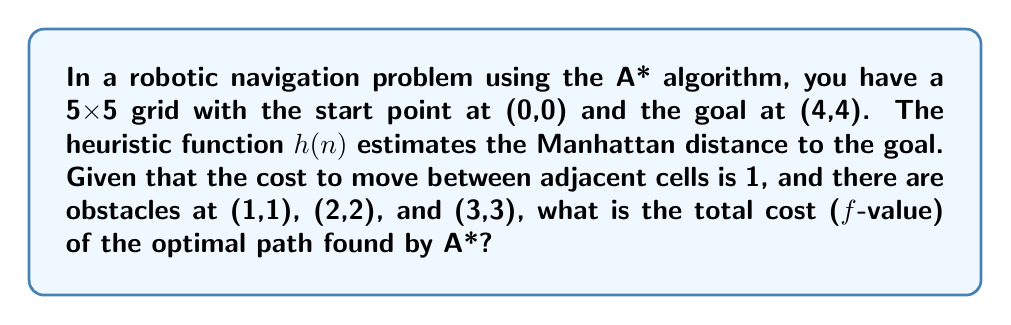Give your solution to this math problem. Let's solve this step-by-step:

1) The A* algorithm uses the formula $f(n) = g(n) + h(n)$, where:
   - $f(n)$ is the total estimated cost of the path through node n
   - $g(n)$ is the actual cost from the start to node n
   - $h(n)$ is the heuristic estimate from n to the goal

2) The Manhattan distance heuristic is calculated as:
   $h(n) = |x_{goal} - x_n| + |y_{goal} - y_n|$

3) The optimal path avoiding obstacles will be:
   (0,0) → (1,0) → (2,0) → (2,1) → (3,1) → (3,2) → (4,2) → (4,3) → (4,4)

4) This path has 8 steps, so $g(goal) = 8$

5) At each step, let's calculate $f(n)$:

   - (0,0): $g=0$, $h=8$, $f=8$
   - (1,0): $g=1$, $h=7$, $f=8$
   - (2,0): $g=2$, $h=6$, $f=8$
   - (2,1): $g=3$, $h=5$, $f=8$
   - (3,1): $g=4$, $h=4$, $f=8$
   - (3,2): $g=5$, $h=3$, $f=8$
   - (4,2): $g=6$, $h=2$, $f=8$
   - (4,3): $g=7$, $h=1$, $f=8$
   - (4,4): $g=8$, $h=0$, $f=8$

6) The total cost (f-value) of the optimal path remains constant at 8 throughout the search.
Answer: 8 